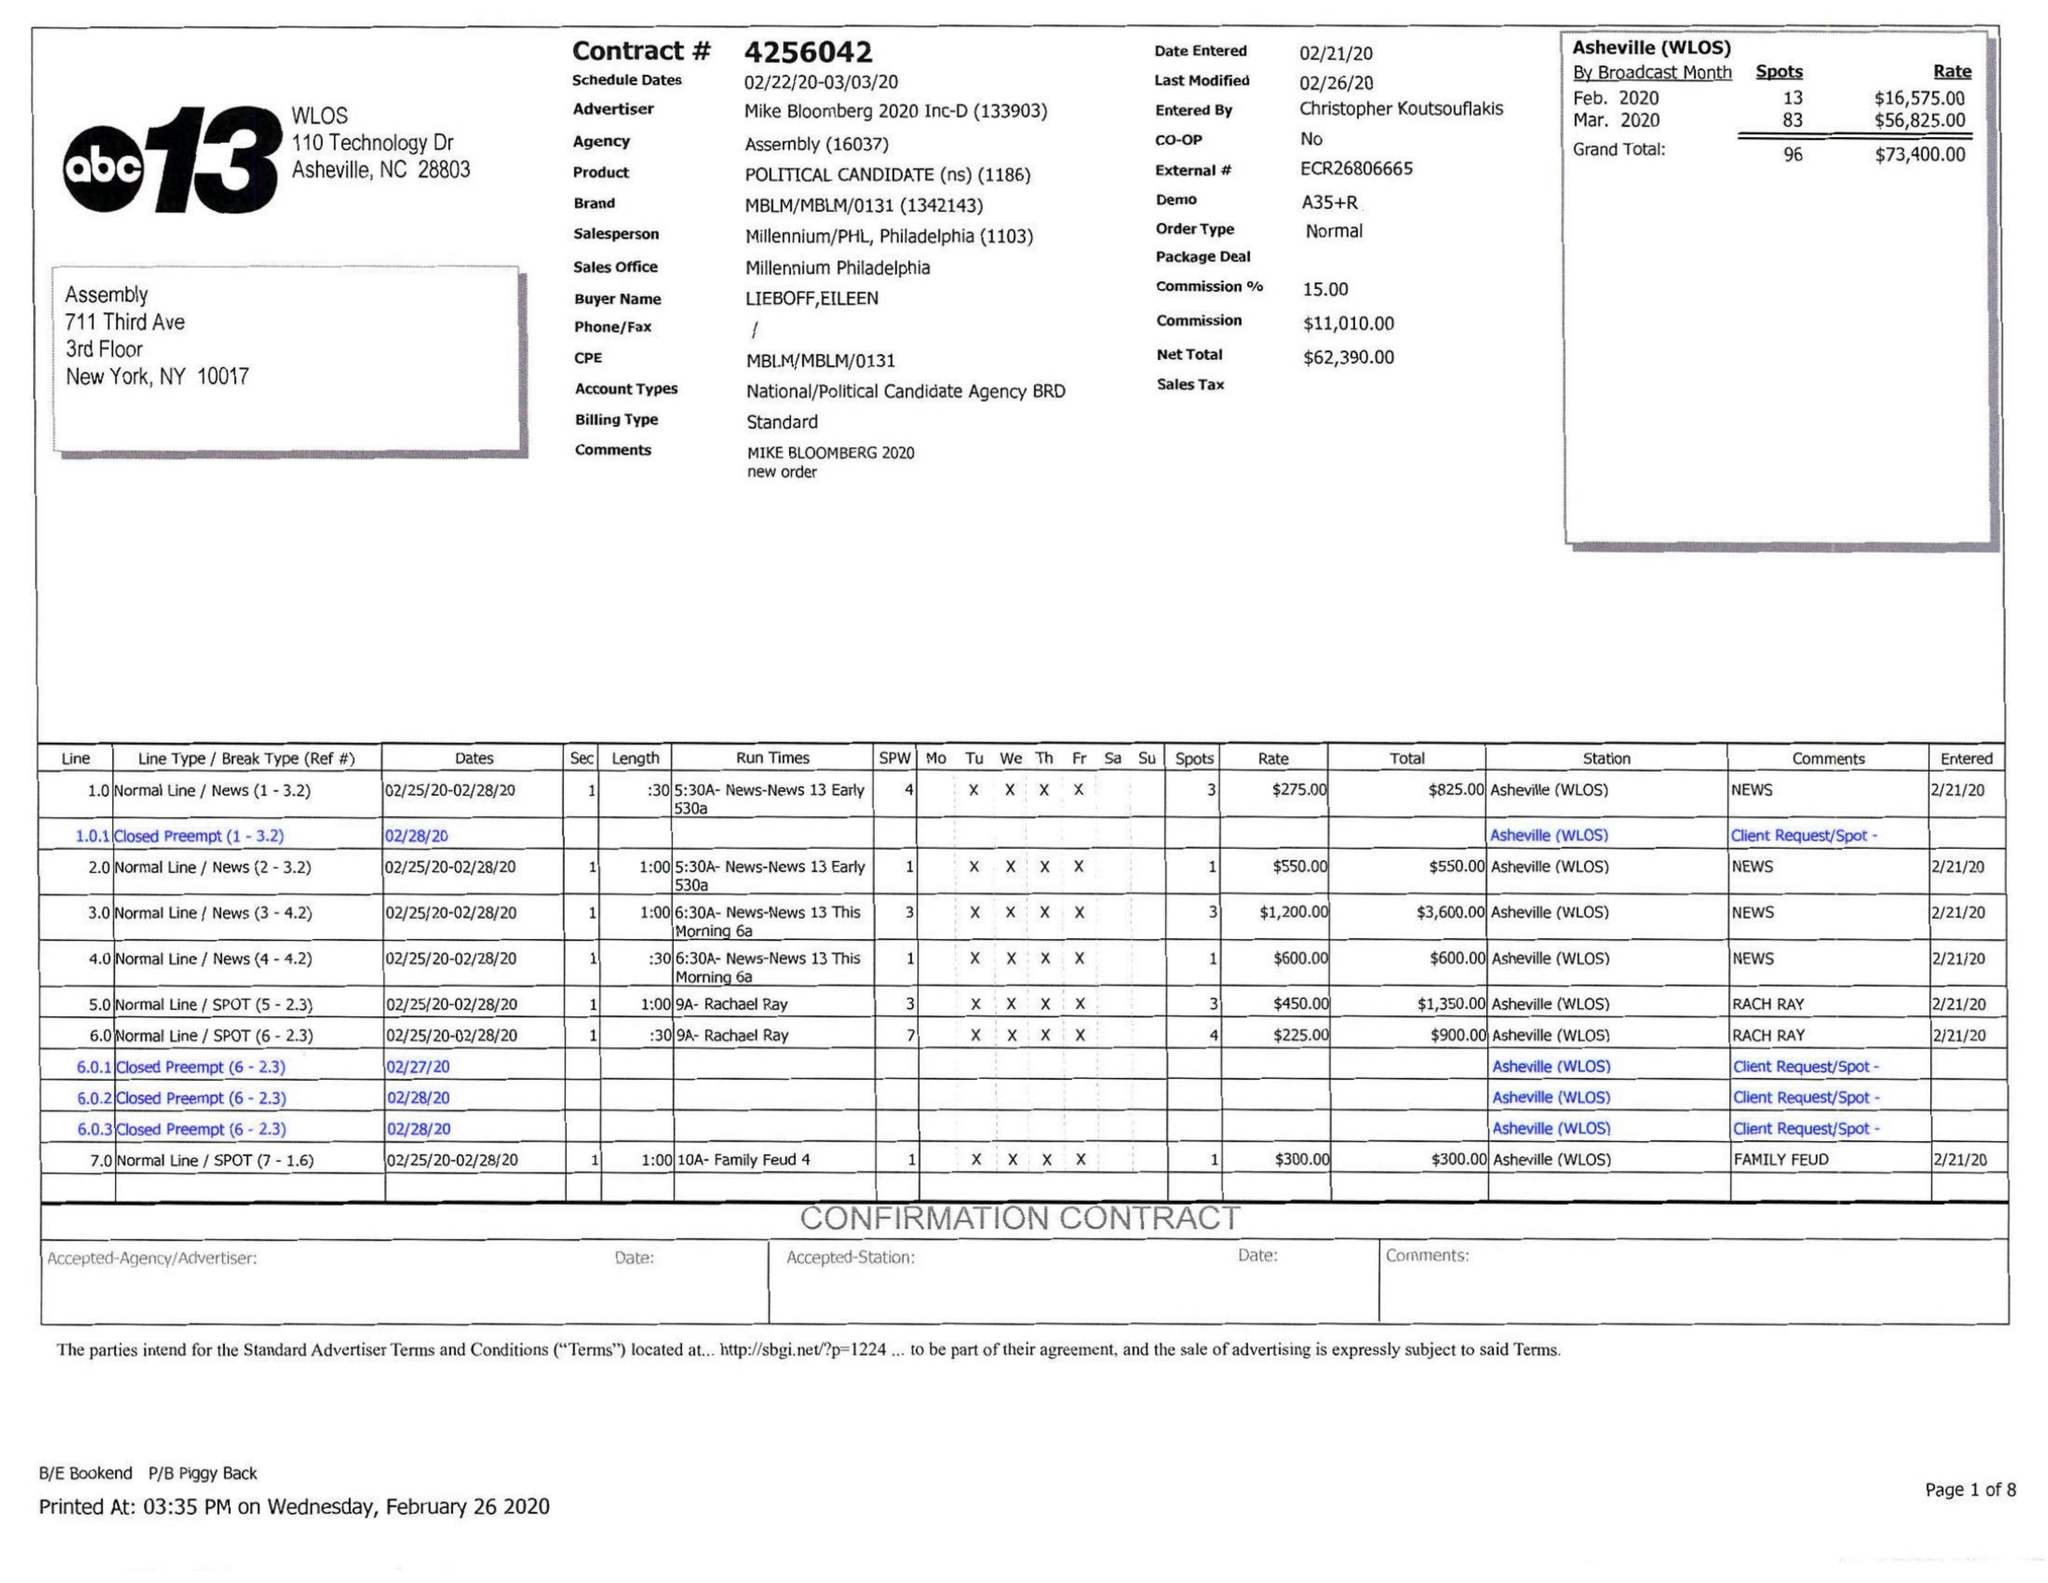What is the value for the flight_to?
Answer the question using a single word or phrase. 03/03/20 